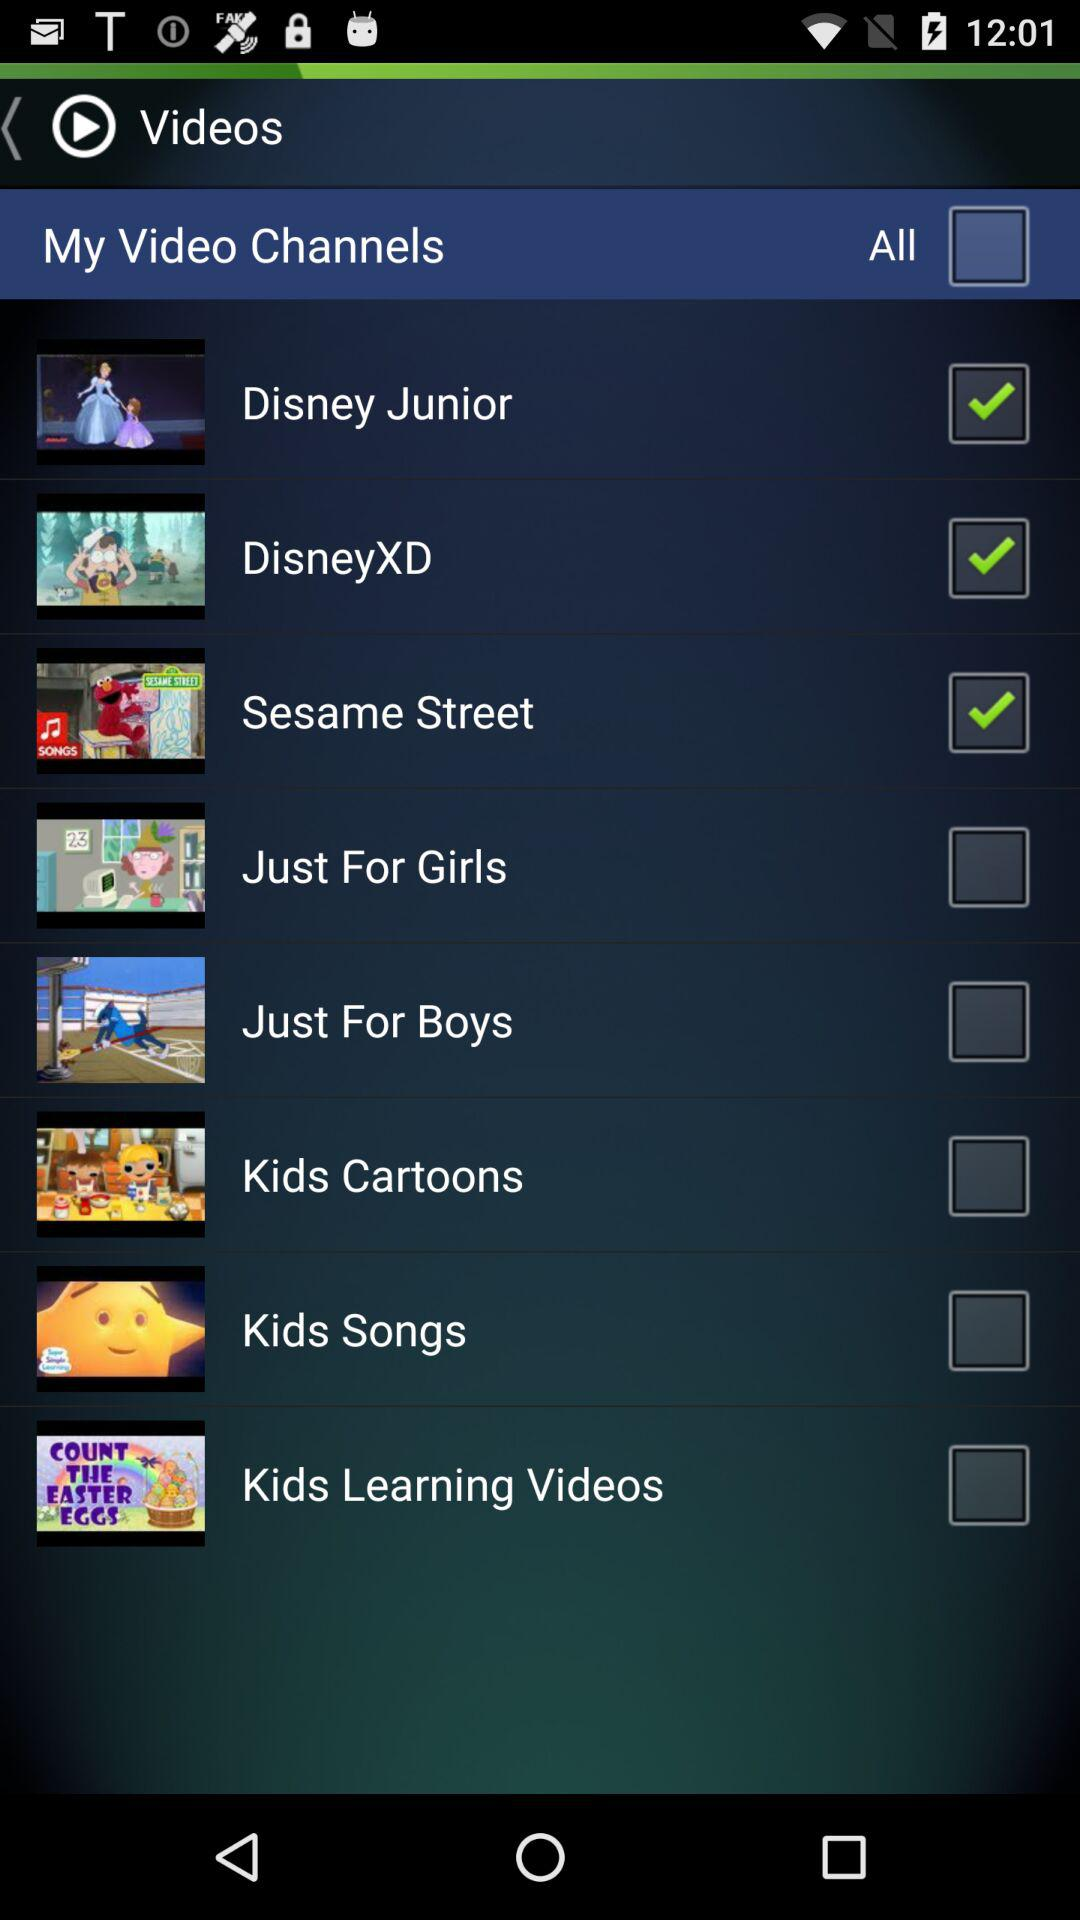How many channels are there in total?
Answer the question using a single word or phrase. 8 